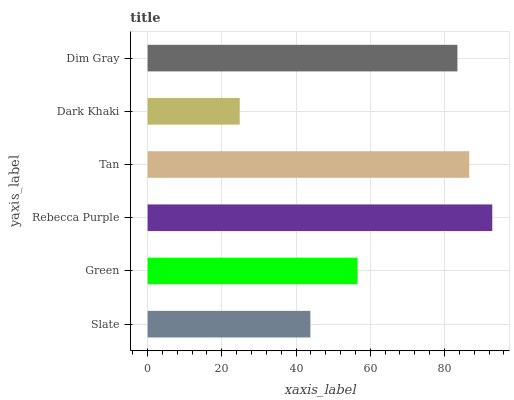Is Dark Khaki the minimum?
Answer yes or no. Yes. Is Rebecca Purple the maximum?
Answer yes or no. Yes. Is Green the minimum?
Answer yes or no. No. Is Green the maximum?
Answer yes or no. No. Is Green greater than Slate?
Answer yes or no. Yes. Is Slate less than Green?
Answer yes or no. Yes. Is Slate greater than Green?
Answer yes or no. No. Is Green less than Slate?
Answer yes or no. No. Is Dim Gray the high median?
Answer yes or no. Yes. Is Green the low median?
Answer yes or no. Yes. Is Green the high median?
Answer yes or no. No. Is Tan the low median?
Answer yes or no. No. 